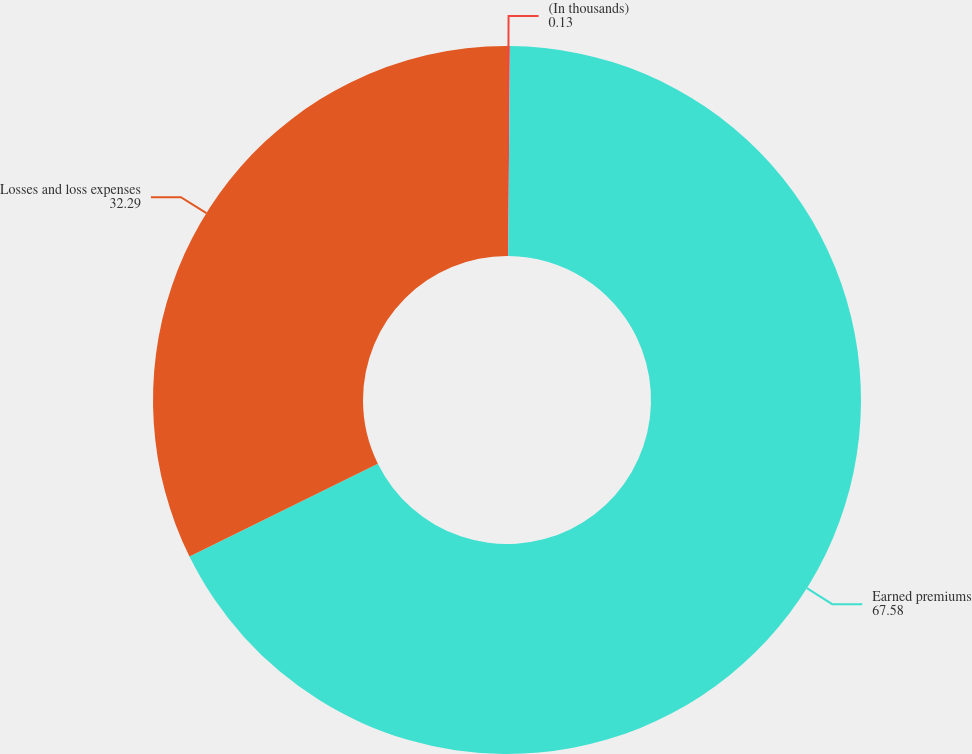Convert chart. <chart><loc_0><loc_0><loc_500><loc_500><pie_chart><fcel>(In thousands)<fcel>Earned premiums<fcel>Losses and loss expenses<nl><fcel>0.13%<fcel>67.58%<fcel>32.29%<nl></chart> 